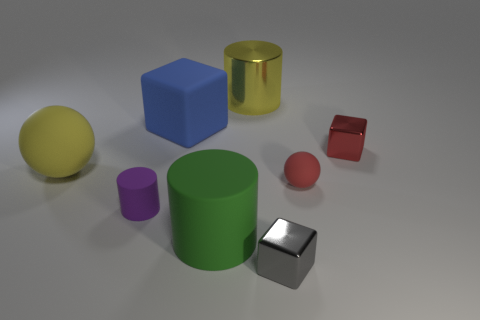There is a small rubber thing on the right side of the small gray shiny object; what is its color?
Provide a succinct answer. Red. Is there a block that is on the right side of the metal block in front of the big matte ball?
Make the answer very short. Yes. Do the small rubber ball and the tiny block behind the red matte object have the same color?
Your answer should be very brief. Yes. Is there a big yellow thing made of the same material as the purple thing?
Provide a succinct answer. Yes. How many large gray metallic things are there?
Ensure brevity in your answer.  0. What is the material of the large yellow thing that is left of the block that is to the left of the large yellow shiny object?
Offer a terse response. Rubber. The cube that is the same material as the yellow ball is what color?
Your response must be concise. Blue. The big thing that is the same color as the big sphere is what shape?
Ensure brevity in your answer.  Cylinder. Do the yellow thing that is in front of the blue rubber block and the cube in front of the big yellow matte object have the same size?
Your answer should be very brief. No. What number of balls are either small purple things or blue things?
Provide a succinct answer. 0. 